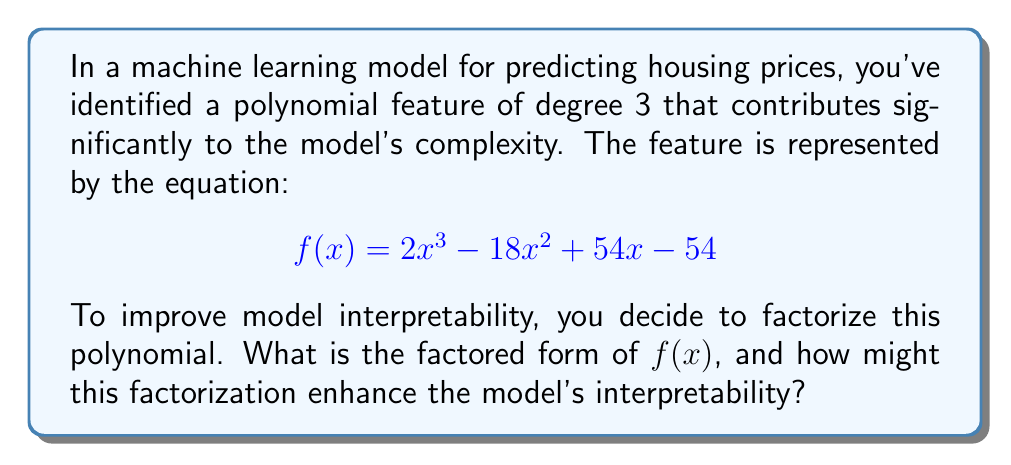Could you help me with this problem? To factorize the polynomial $f(x) = 2x^3 - 18x^2 + 54x - 54$, we'll follow these steps:

1. First, factor out the greatest common factor (GCF):
   $$f(x) = 2(x^3 - 9x^2 + 27x - 27)$$

2. The expression inside the parentheses is a cubic polynomial. Let's check if it's a perfect cube by trying to factor it as $(x - a)^3$:
   $$(x - 3)^3 = x^3 - 9x^2 + 27x - 27$$

3. This matches our polynomial inside the parentheses, so we can rewrite $f(x)$ as:
   $$f(x) = 2(x - 3)^3$$

4. Therefore, the fully factored form is:
   $$f(x) = 2(x - 3)(x - 3)(x - 3)$$

This factorization enhances the model's interpretability in several ways:

a) It reveals that the feature has a single root at $x = 3$, repeated three times.
b) The coefficient 2 shows the overall scale of the feature's impact.
c) The cubic nature $(x - 3)^3$ indicates that the feature's effect grows rapidly as $x$ moves away from 3 in either direction.
d) This form makes it easier to understand how changes in $x$ affect the output, especially near the critical point $x = 3$.

For a machine learning practitioner, this factorization suggests that the model is particularly sensitive to whether the input is above or below 3, and that there's a significant nonlinear relationship around this point. This insight could lead to more informed feature engineering, such as creating boolean features based on this threshold or considering piecewise linear approximations around $x = 3$.
Answer: $f(x) = 2(x - 3)^3$ 